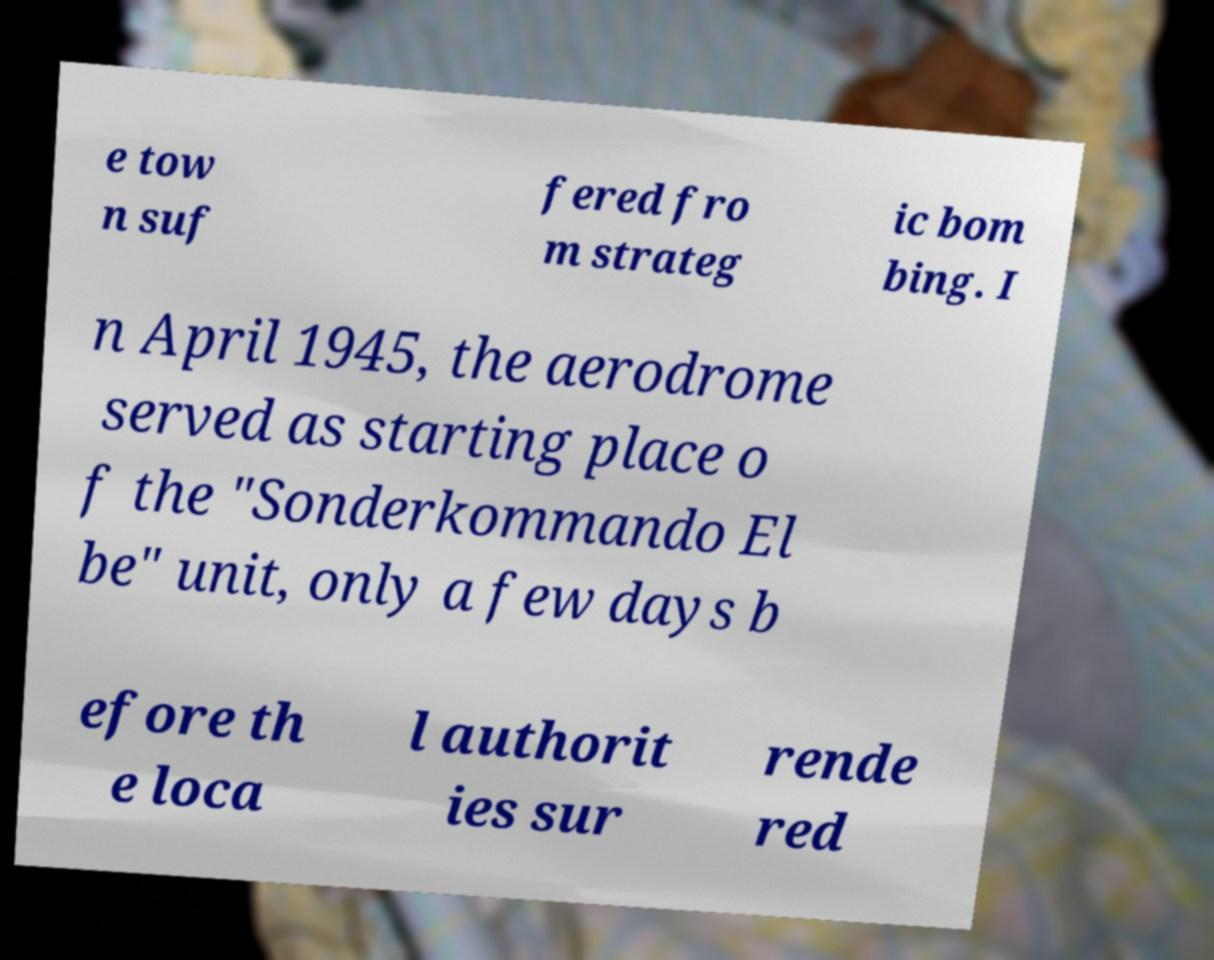I need the written content from this picture converted into text. Can you do that? e tow n suf fered fro m strateg ic bom bing. I n April 1945, the aerodrome served as starting place o f the "Sonderkommando El be" unit, only a few days b efore th e loca l authorit ies sur rende red 